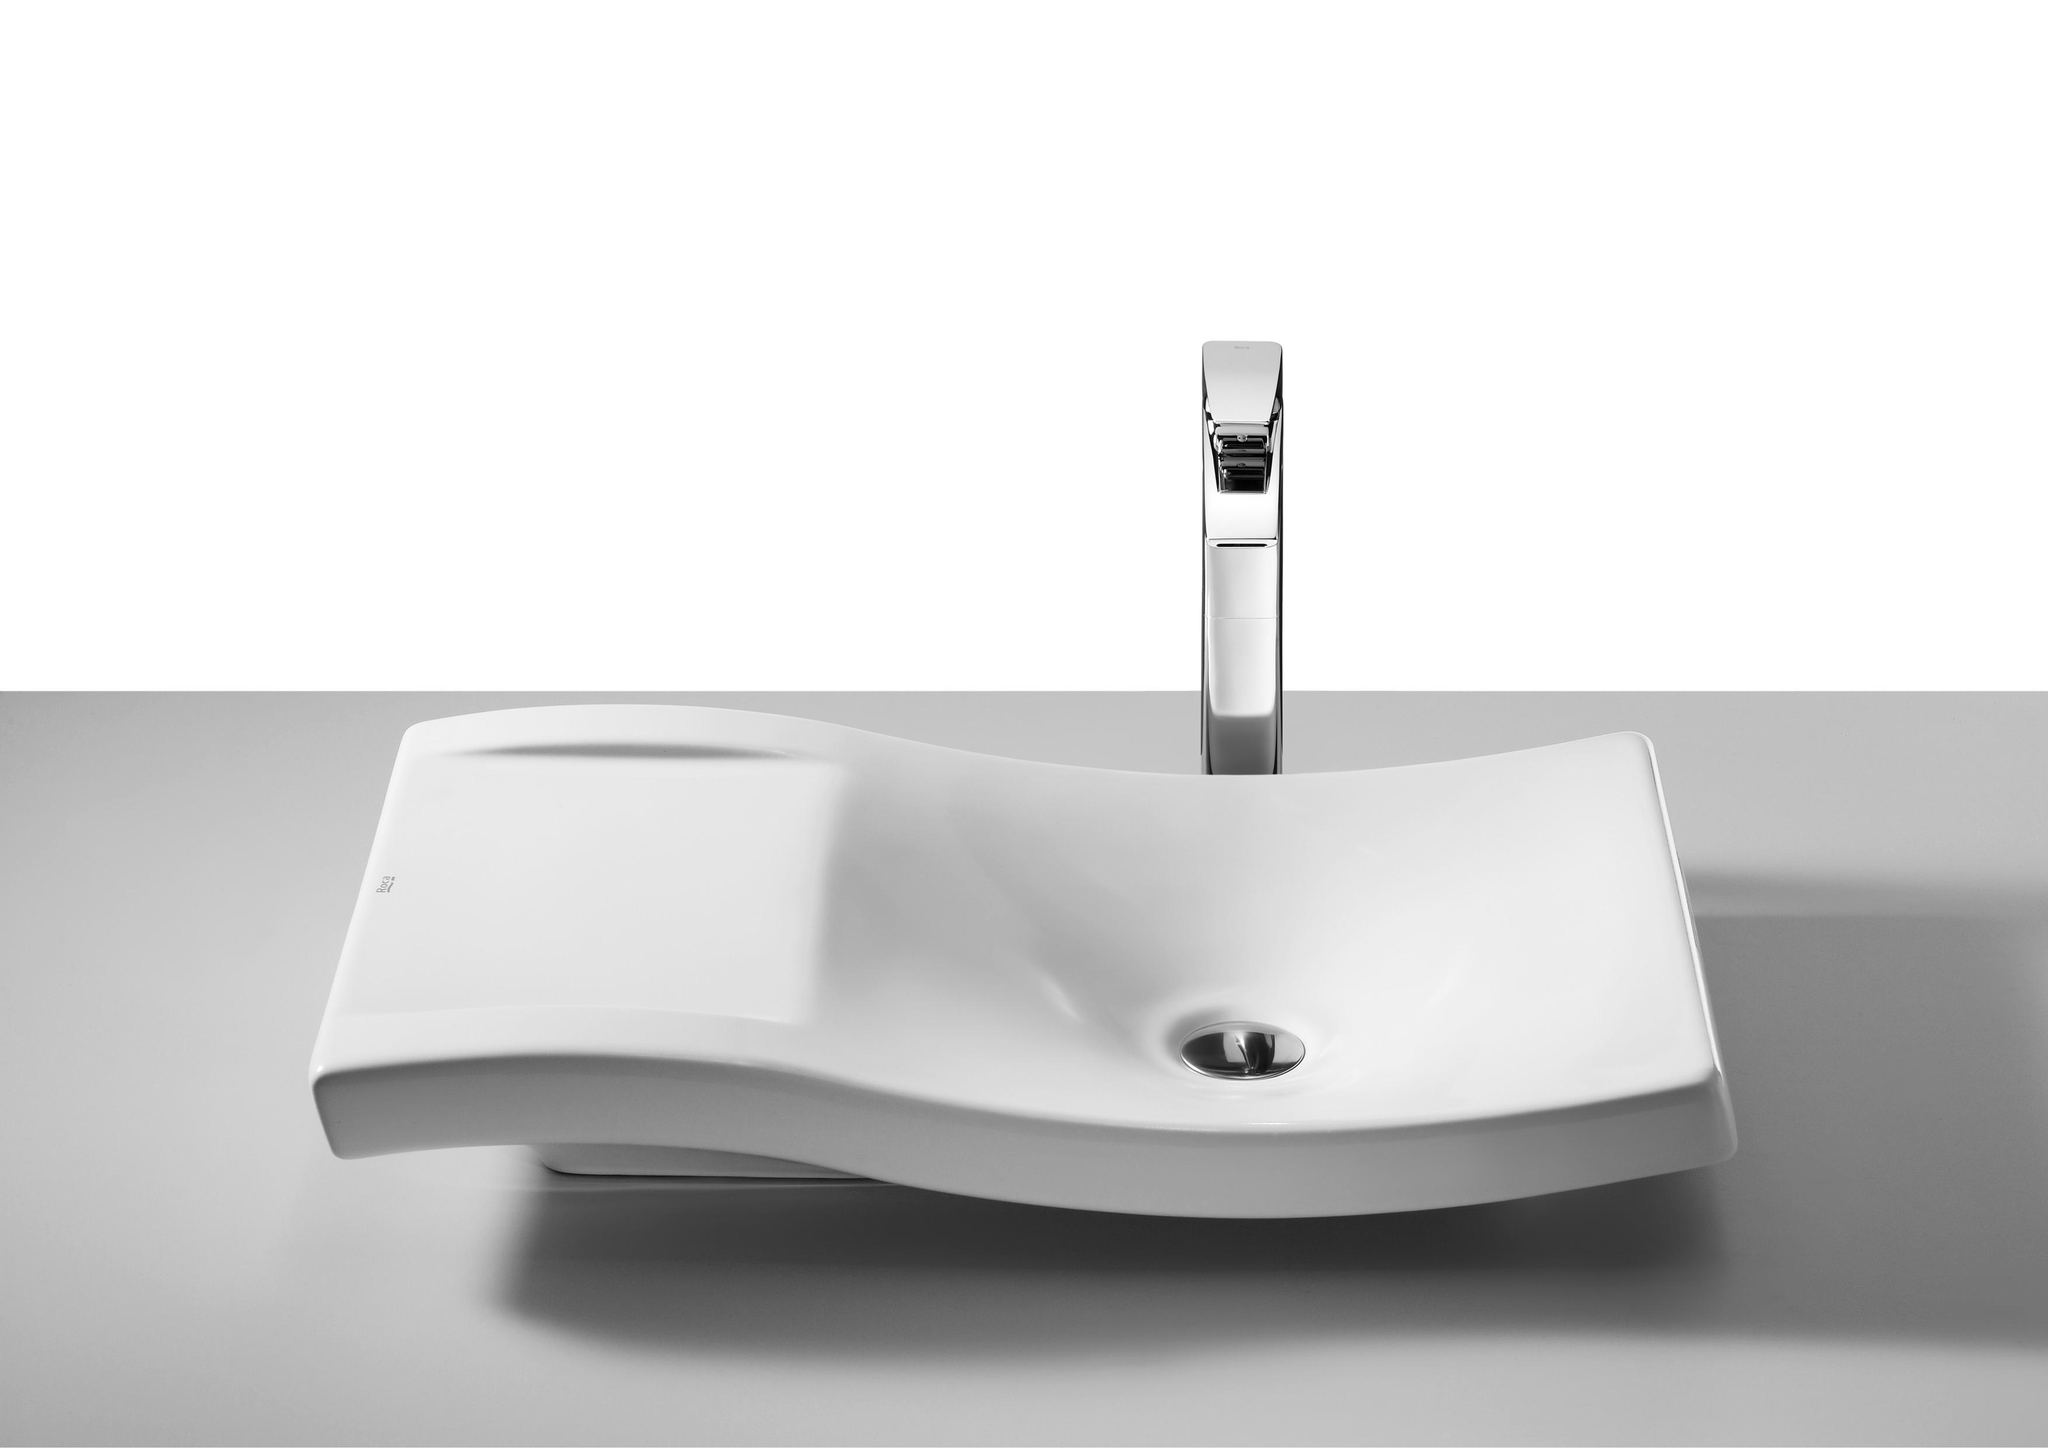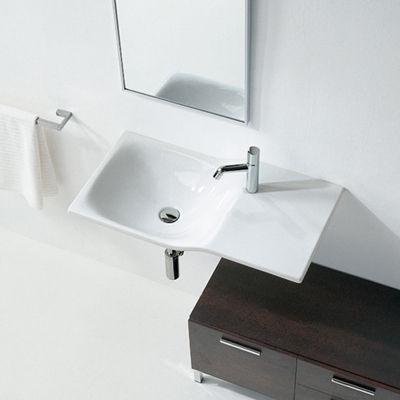The first image is the image on the left, the second image is the image on the right. Evaluate the accuracy of this statement regarding the images: "A vanity includes one rectangular white sink and a brown cabinet with multiple drawers.". Is it true? Answer yes or no. No. The first image is the image on the left, the second image is the image on the right. For the images shown, is this caption "In at least one image, a mirror is clearly visible above a bathroom sink" true? Answer yes or no. Yes. 